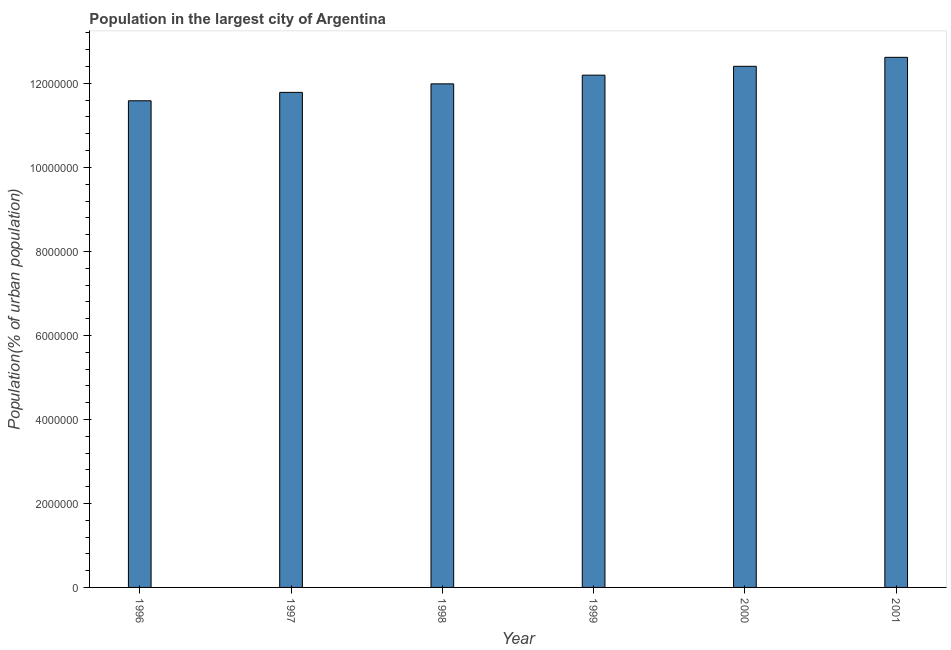What is the title of the graph?
Offer a terse response. Population in the largest city of Argentina. What is the label or title of the X-axis?
Ensure brevity in your answer.  Year. What is the label or title of the Y-axis?
Your answer should be compact. Population(% of urban population). What is the population in largest city in 2000?
Offer a very short reply. 1.24e+07. Across all years, what is the maximum population in largest city?
Provide a succinct answer. 1.26e+07. Across all years, what is the minimum population in largest city?
Ensure brevity in your answer.  1.16e+07. In which year was the population in largest city minimum?
Your response must be concise. 1996. What is the sum of the population in largest city?
Your answer should be very brief. 7.26e+07. What is the difference between the population in largest city in 1999 and 2001?
Your answer should be very brief. -4.24e+05. What is the average population in largest city per year?
Make the answer very short. 1.21e+07. What is the median population in largest city?
Provide a short and direct response. 1.21e+07. Do a majority of the years between 1999 and 1998 (inclusive) have population in largest city greater than 8000000 %?
Offer a very short reply. No. Is the population in largest city in 1998 less than that in 1999?
Offer a terse response. Yes. Is the difference between the population in largest city in 1998 and 1999 greater than the difference between any two years?
Keep it short and to the point. No. What is the difference between the highest and the second highest population in largest city?
Your response must be concise. 2.14e+05. What is the difference between the highest and the lowest population in largest city?
Offer a terse response. 1.03e+06. In how many years, is the population in largest city greater than the average population in largest city taken over all years?
Your response must be concise. 3. Are all the bars in the graph horizontal?
Ensure brevity in your answer.  No. What is the Population(% of urban population) in 1996?
Your answer should be very brief. 1.16e+07. What is the Population(% of urban population) of 1997?
Keep it short and to the point. 1.18e+07. What is the Population(% of urban population) of 1998?
Your answer should be very brief. 1.20e+07. What is the Population(% of urban population) in 1999?
Your answer should be very brief. 1.22e+07. What is the Population(% of urban population) in 2000?
Provide a short and direct response. 1.24e+07. What is the Population(% of urban population) of 2001?
Make the answer very short. 1.26e+07. What is the difference between the Population(% of urban population) in 1996 and 1997?
Make the answer very short. -2.00e+05. What is the difference between the Population(% of urban population) in 1996 and 1998?
Keep it short and to the point. -4.03e+05. What is the difference between the Population(% of urban population) in 1996 and 1999?
Offer a very short reply. -6.10e+05. What is the difference between the Population(% of urban population) in 1996 and 2000?
Provide a succinct answer. -8.20e+05. What is the difference between the Population(% of urban population) in 1996 and 2001?
Provide a short and direct response. -1.03e+06. What is the difference between the Population(% of urban population) in 1997 and 1998?
Offer a very short reply. -2.03e+05. What is the difference between the Population(% of urban population) in 1997 and 1999?
Provide a short and direct response. -4.10e+05. What is the difference between the Population(% of urban population) in 1997 and 2000?
Ensure brevity in your answer.  -6.21e+05. What is the difference between the Population(% of urban population) in 1997 and 2001?
Ensure brevity in your answer.  -8.35e+05. What is the difference between the Population(% of urban population) in 1998 and 1999?
Provide a short and direct response. -2.07e+05. What is the difference between the Population(% of urban population) in 1998 and 2000?
Your answer should be very brief. -4.18e+05. What is the difference between the Population(% of urban population) in 1998 and 2001?
Give a very brief answer. -6.31e+05. What is the difference between the Population(% of urban population) in 1999 and 2000?
Provide a short and direct response. -2.11e+05. What is the difference between the Population(% of urban population) in 1999 and 2001?
Your response must be concise. -4.24e+05. What is the difference between the Population(% of urban population) in 2000 and 2001?
Give a very brief answer. -2.14e+05. What is the ratio of the Population(% of urban population) in 1996 to that in 2000?
Keep it short and to the point. 0.93. What is the ratio of the Population(% of urban population) in 1996 to that in 2001?
Provide a succinct answer. 0.92. What is the ratio of the Population(% of urban population) in 1997 to that in 1999?
Offer a very short reply. 0.97. What is the ratio of the Population(% of urban population) in 1997 to that in 2001?
Make the answer very short. 0.93. What is the ratio of the Population(% of urban population) in 1998 to that in 1999?
Your answer should be compact. 0.98. What is the ratio of the Population(% of urban population) in 1998 to that in 2000?
Offer a very short reply. 0.97. What is the ratio of the Population(% of urban population) in 1999 to that in 2001?
Your answer should be very brief. 0.97. 